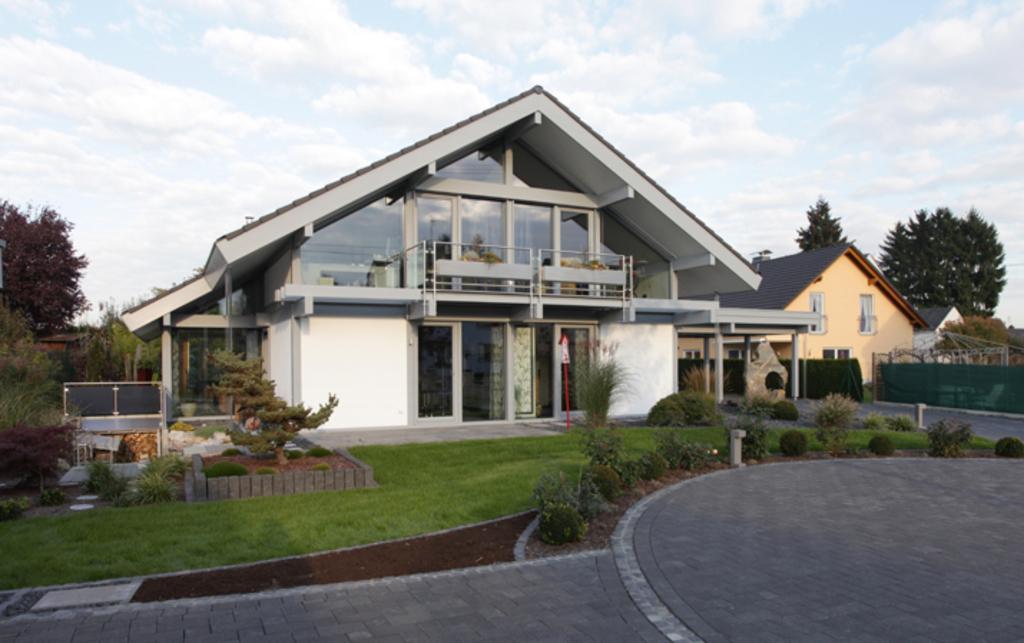Please provide a concise description of this image. Here in this picture we can see houses present all over there and we can see plants and trees present here and there and we can see the ground is covered with grass over there and we can see clouds in sky. 